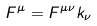Convert formula to latex. <formula><loc_0><loc_0><loc_500><loc_500>F ^ { \mu } = F ^ { \mu \nu } k _ { \nu }</formula> 